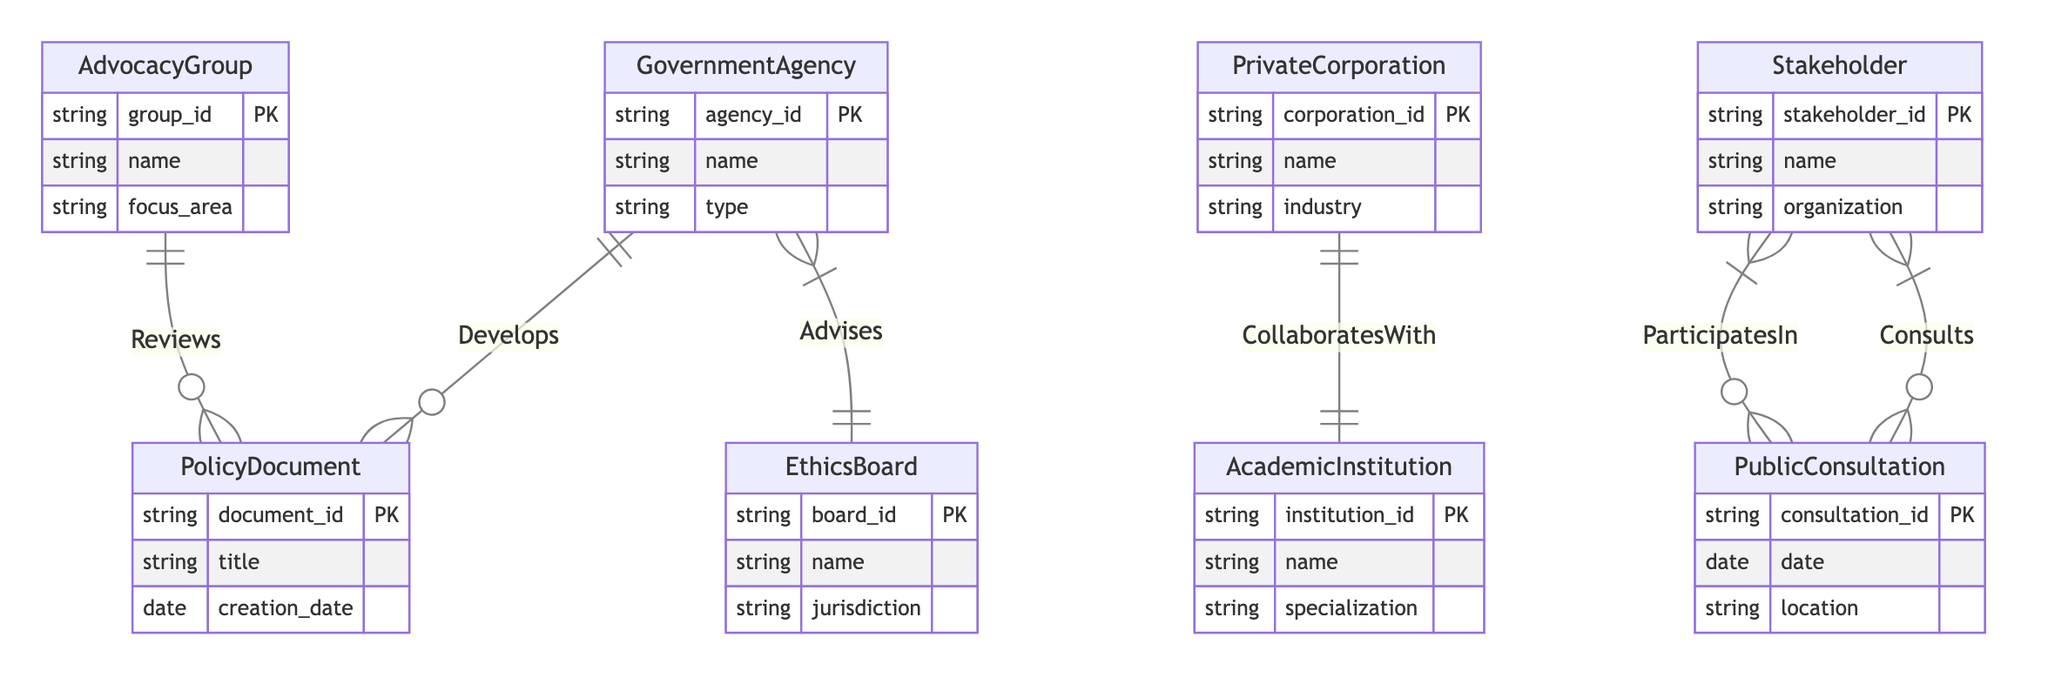What is the primary entity that develops policy documents? The diagram shows a one-to-many relationship between the GovernmentAgency and PolicyDocument, indicating that GovernmentAgency is the entity responsible for developing policy documents.
Answer: GovernmentAgency How many relationships are depicted in the diagram? By counting the relationships shown in the diagram, we see six distinct relationships, namely Develops, Advises, CollaboratesWith, Consults, Reviews, and ParticipatesIn.
Answer: Six Which entity advises the Government Agency? The diagram illustrates a direct relationship between the EthicsBoard and the GovernmentAgency labeled as Advises, indicating that EthicsBoard is the entity providing advice to the GovernmentAgency.
Answer: EthicsBoard What type of entity collaborates with Academic Institutions? The diagram indicates a relationship labeled CollaboratesWith between PrivateCorporation and AcademicInstitution, demonstrating that PrivateCorporation is the entity that collaborates with Academic Institutions.
Answer: PrivateCorporation What is the participation role of Stakeholders in public consultations? The diagram includes a relationship named ParticipatesIn between Stakeholder and PublicConsultation, indicating that Stakeholders have a defined role in these consultations. To find the specific role, one would need to reference the specific data associated with the relationship.
Answer: participation_role How many entities are involved in creating policy documents? Upon reviewing the diagram, the entities involved in creating policy documents are the GovernmentAgency and AdvocacyGroup, as the GovernmentAgency develops them and the AdvocacyGroup reviews them, indicating that there are two distinct entities involved.
Answer: Two What kind of documents do Advocacy Groups typically review? The relationship labeled Reviews in the diagram connects AdvocacyGroup and PolicyDocument, indicating that Advocacy Groups are involved in reviewing policy documents.
Answer: Policy documents Which entity focuses specifically on ethics? The diagram includes the EthicsBoard, which has a direct advisory relationship with the GovernmentAgency, highlighting its focus specifically on ethical advice related to policies.
Answer: EthicsBoard 